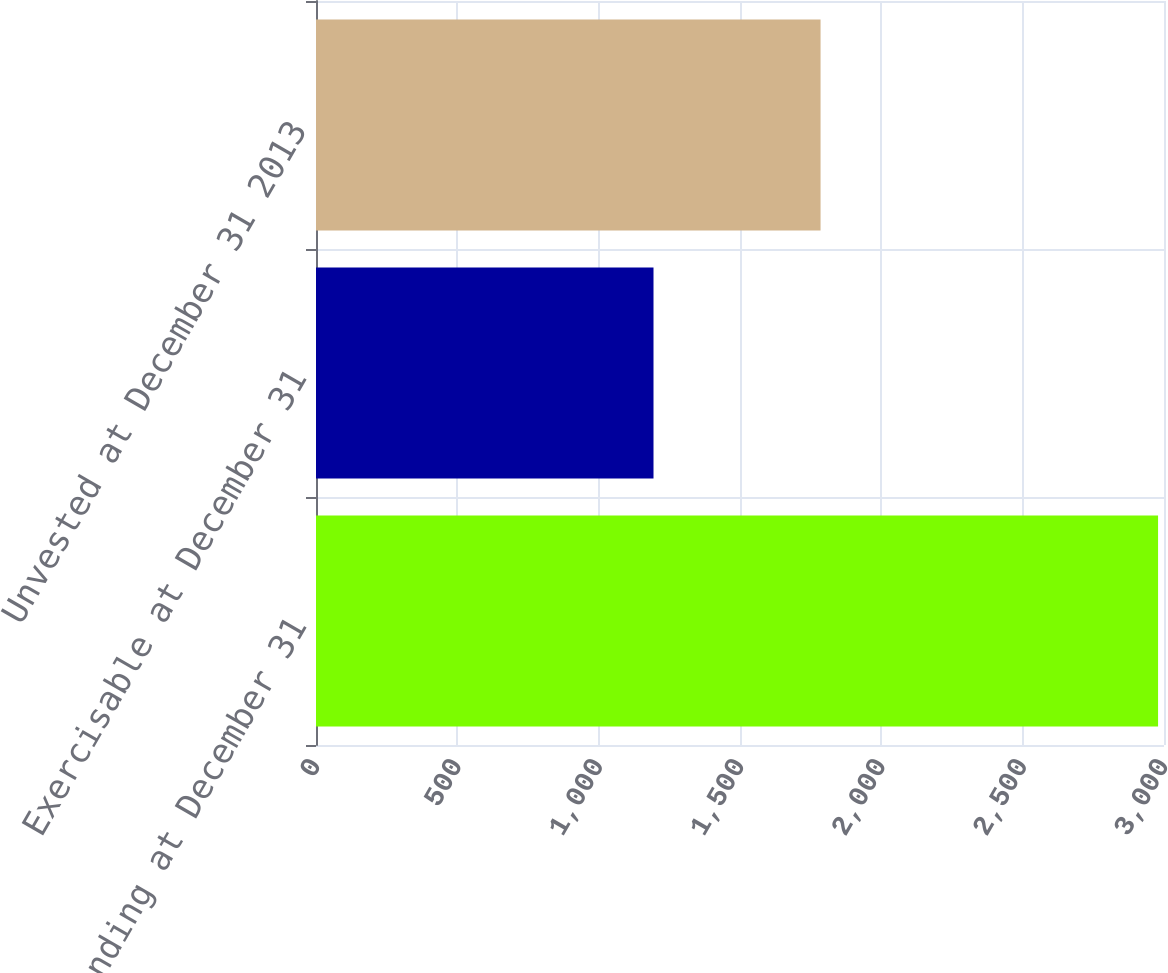<chart> <loc_0><loc_0><loc_500><loc_500><bar_chart><fcel>Outstanding at December 31<fcel>Exercisable at December 31<fcel>Unvested at December 31 2013<nl><fcel>2979<fcel>1194<fcel>1785<nl></chart> 